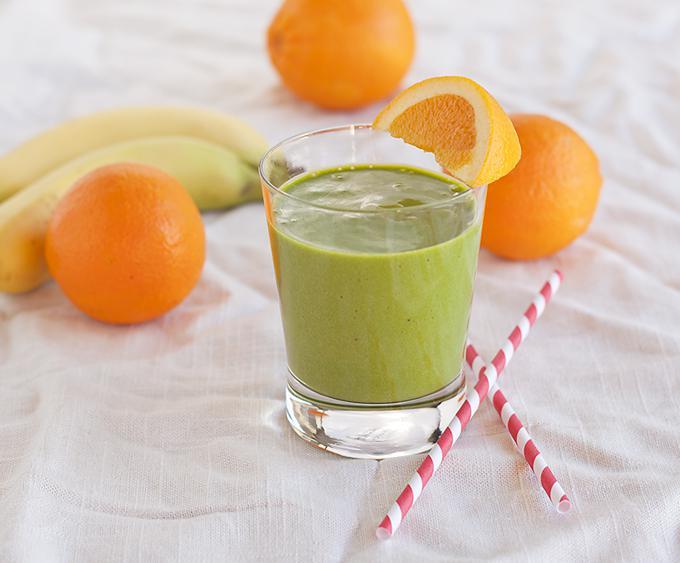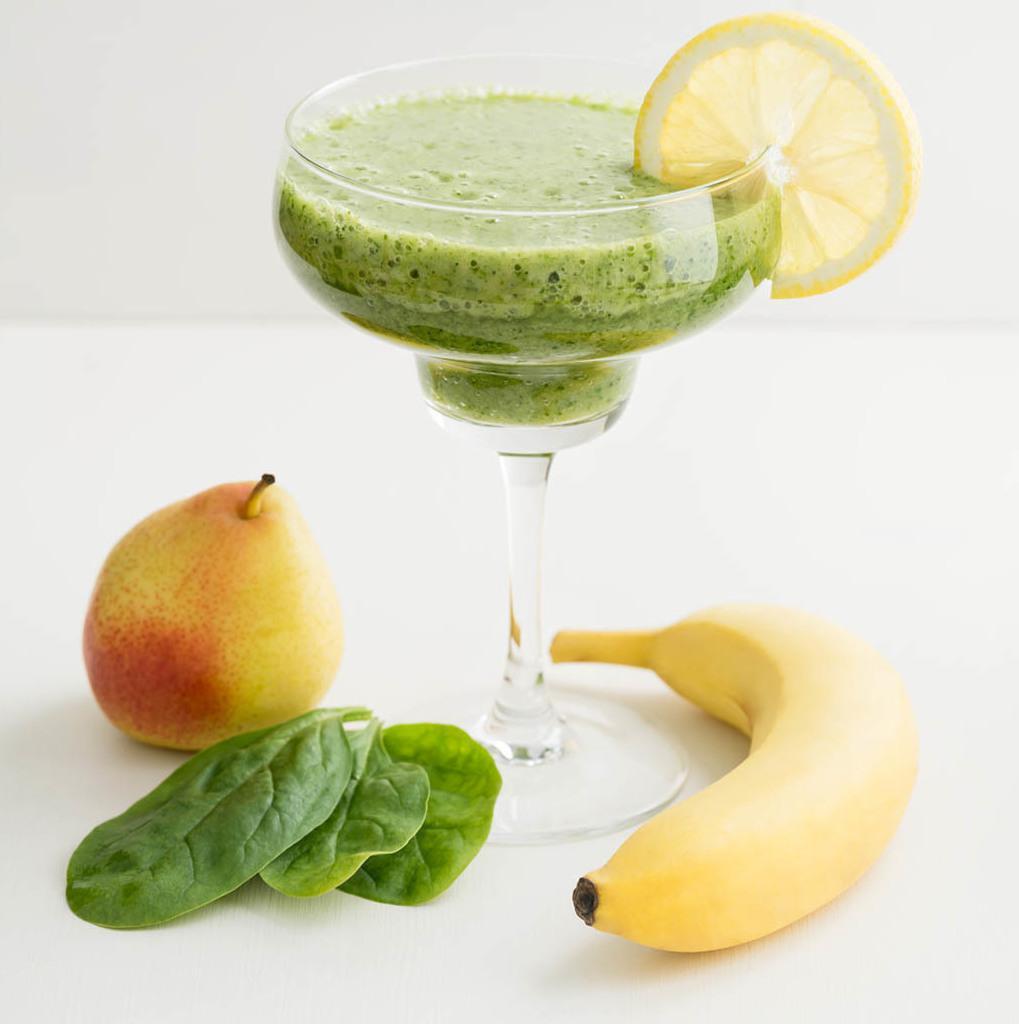The first image is the image on the left, the second image is the image on the right. For the images shown, is this caption "The image on the left has at least one striped straw." true? Answer yes or no. Yes. The first image is the image on the left, the second image is the image on the right. For the images displayed, is the sentence "An image shows exactly one creamy green drink served in a footed glass." factually correct? Answer yes or no. Yes. 